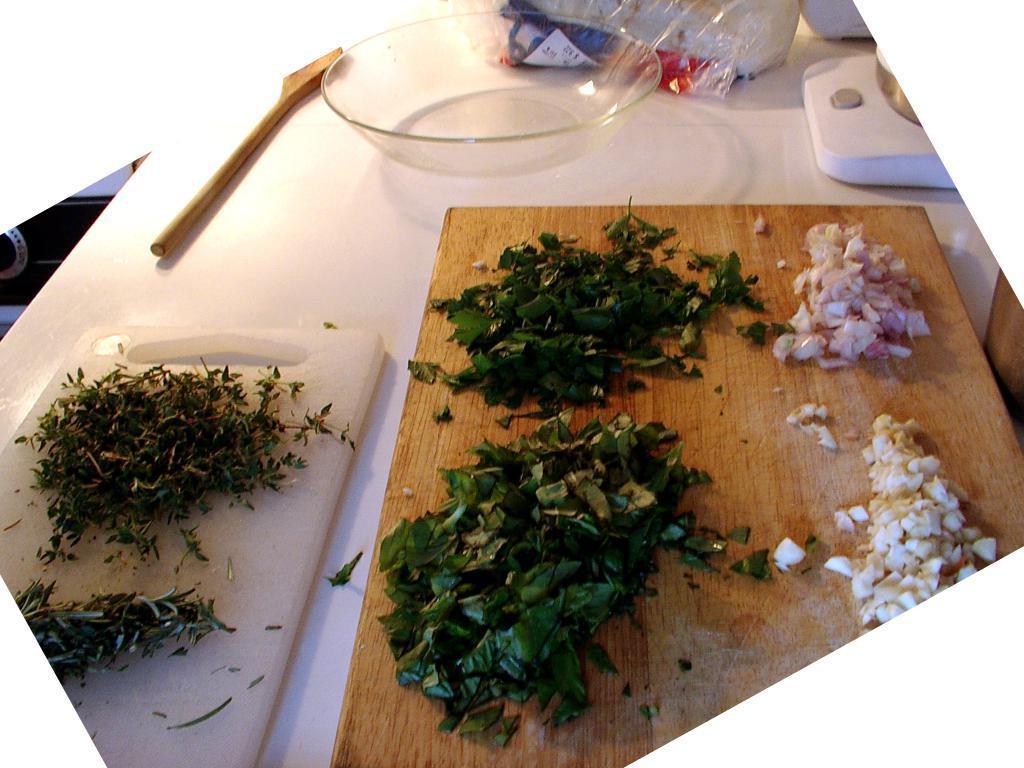How would you summarize this image in a sentence or two? There are pieces of leaves are present on the chop boards at the bottom of this image. There is a bowl and a wooden stick and some other objects are kept on a white color surface. 